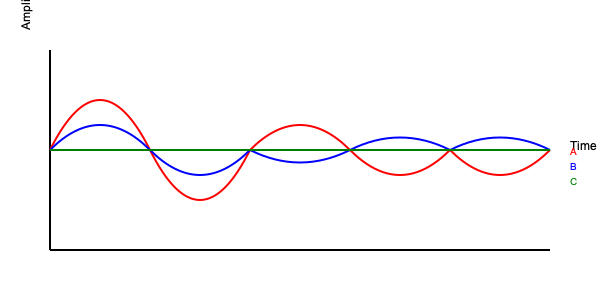As a VoIP termination service provider, which of the waveforms (A, B, or C) represents the highest voice quality and best call clarity? To determine which waveform represents the highest voice quality and best call clarity, we need to analyze each waveform:

1. Waveform A (Red):
   - Shows significant variations in amplitude
   - Has sharp peaks and troughs
   - Indicates high distortion and noise

2. Waveform B (Blue):
   - Shows moderate variations in amplitude
   - Has smoother curves compared to A
   - Indicates some distortion but better than A

3. Waveform C (Green):
   - Shows minimal variations in amplitude
   - Has a nearly straight line
   - Indicates minimal distortion and noise

In VoIP systems, waveforms with less distortion and noise generally represent higher voice quality and better call clarity. The ideal waveform should have minimal variations and a smooth, consistent pattern.

Waveform C (Green) exhibits these characteristics:
- It has the least variation in amplitude
- It shows a consistent, stable signal
- It indicates minimal distortion and noise

Therefore, Waveform C represents the highest voice quality and best call clarity among the three options.
Answer: C 